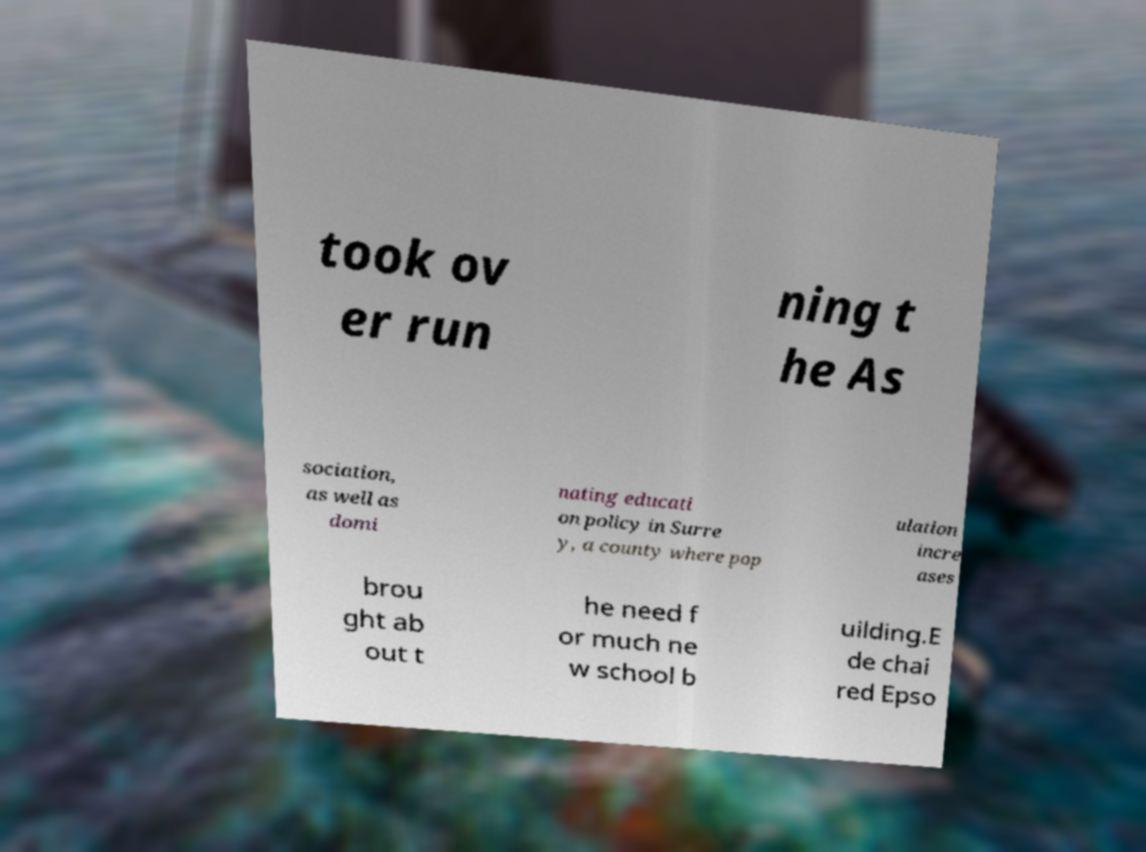Can you read and provide the text displayed in the image?This photo seems to have some interesting text. Can you extract and type it out for me? took ov er run ning t he As sociation, as well as domi nating educati on policy in Surre y, a county where pop ulation incre ases brou ght ab out t he need f or much ne w school b uilding.E de chai red Epso 